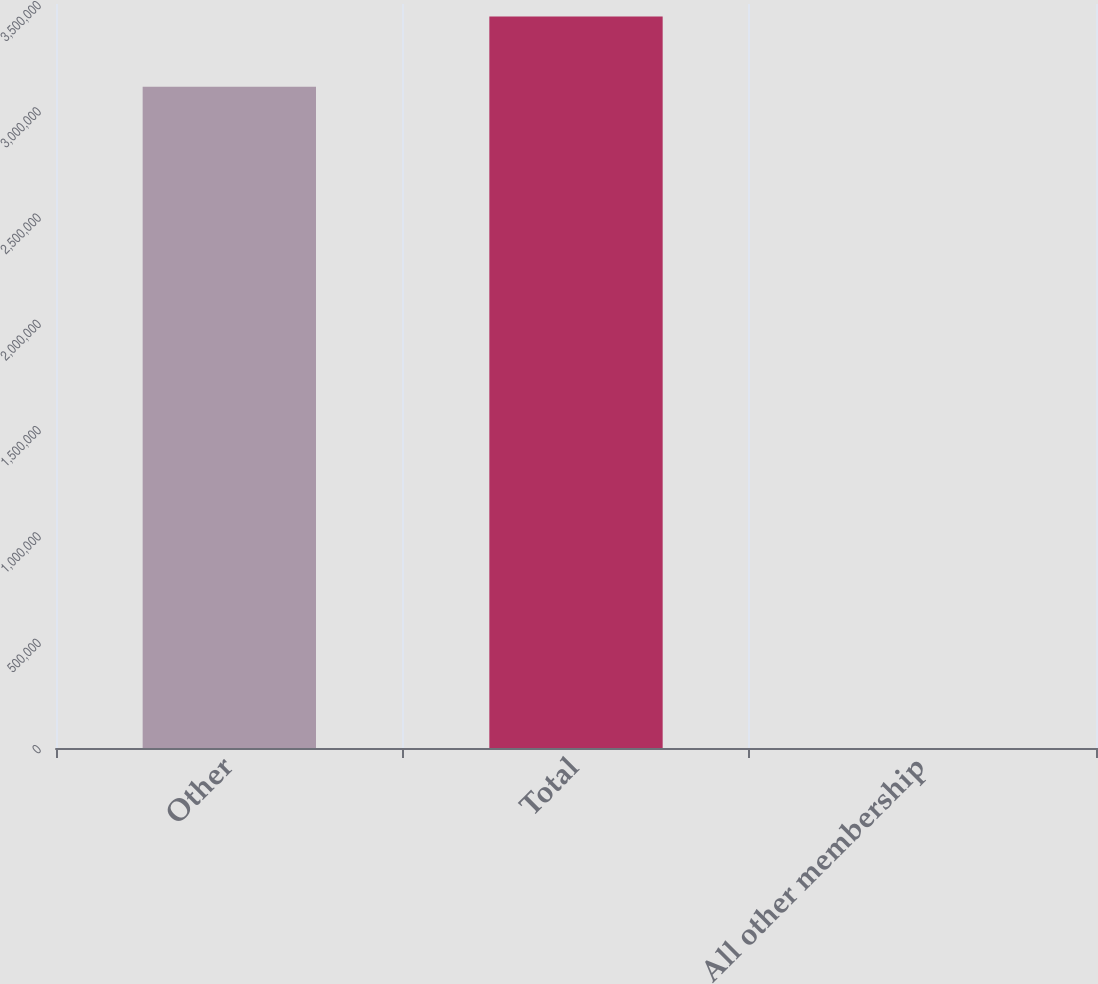<chart> <loc_0><loc_0><loc_500><loc_500><bar_chart><fcel>Other<fcel>Total<fcel>All other membership<nl><fcel>3.1105e+06<fcel>3.441e+06<fcel>94.1<nl></chart> 